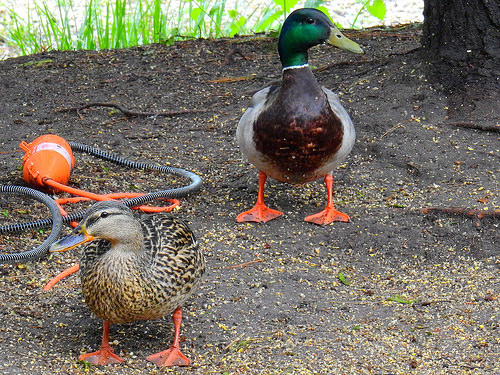<image>
Is the duck under the duck? No. The duck is not positioned under the duck. The vertical relationship between these objects is different. Is the duck behind the tree? No. The duck is not behind the tree. From this viewpoint, the duck appears to be positioned elsewhere in the scene. 